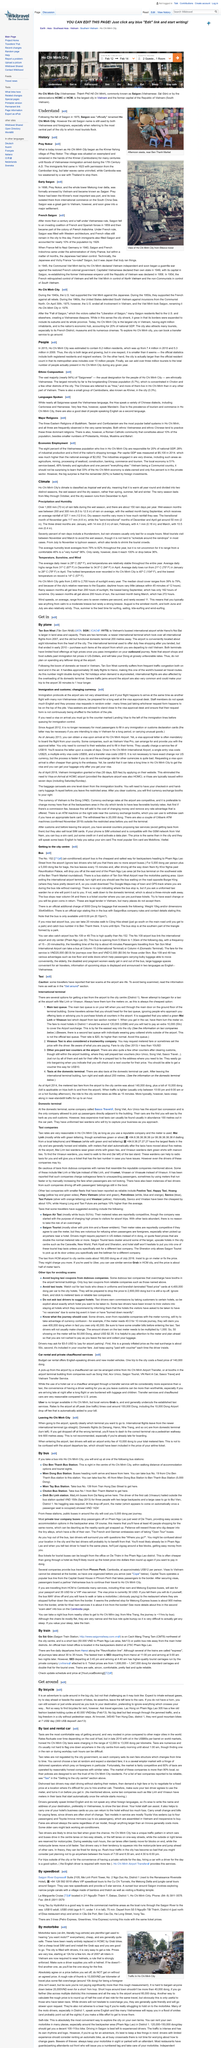Highlight a few significant elements in this photo. Prey Nokor, a village situated on swampland, was a place that was once home to many people. Vietnamese immigrants began settling in the village of Prey Nokor during the 17th century AD. Ho Chi Minh City, formerly known as Saigon, began as the Khmer fishing village of Prey Nokor. 